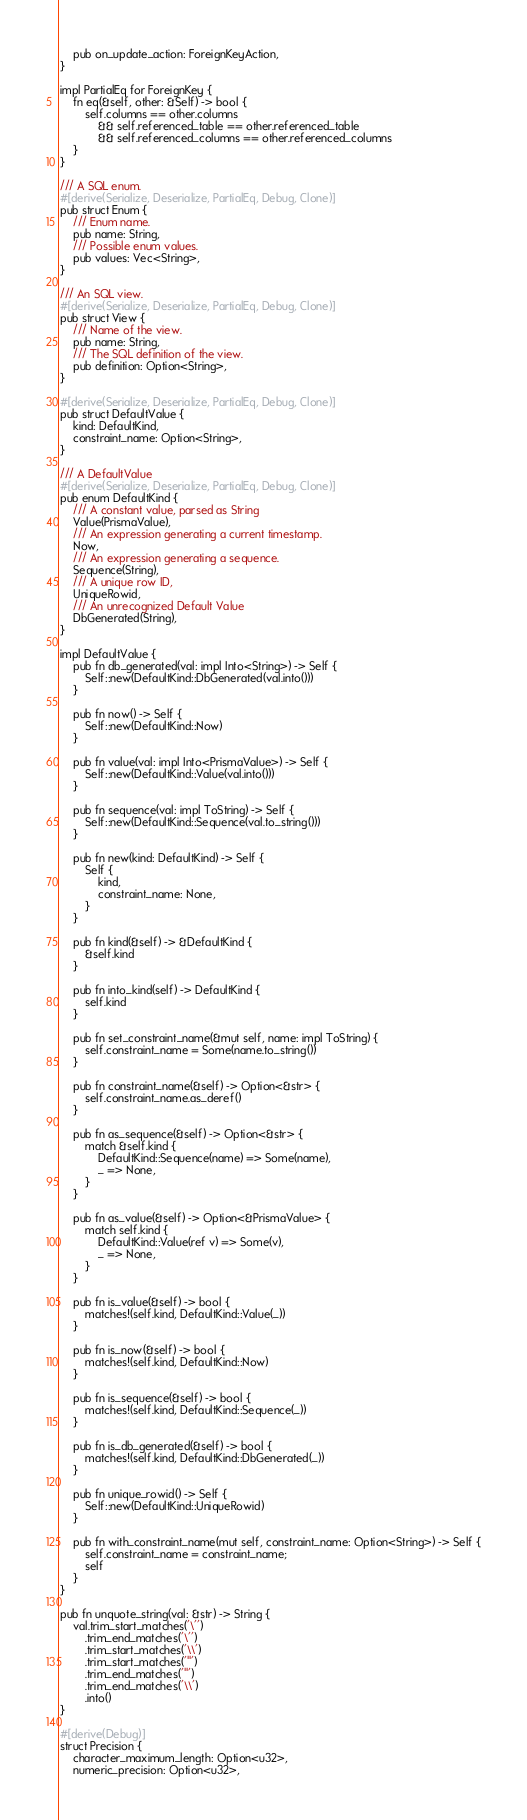Convert code to text. <code><loc_0><loc_0><loc_500><loc_500><_Rust_>    pub on_update_action: ForeignKeyAction,
}

impl PartialEq for ForeignKey {
    fn eq(&self, other: &Self) -> bool {
        self.columns == other.columns
            && self.referenced_table == other.referenced_table
            && self.referenced_columns == other.referenced_columns
    }
}

/// A SQL enum.
#[derive(Serialize, Deserialize, PartialEq, Debug, Clone)]
pub struct Enum {
    /// Enum name.
    pub name: String,
    /// Possible enum values.
    pub values: Vec<String>,
}

/// An SQL view.
#[derive(Serialize, Deserialize, PartialEq, Debug, Clone)]
pub struct View {
    /// Name of the view.
    pub name: String,
    /// The SQL definition of the view.
    pub definition: Option<String>,
}

#[derive(Serialize, Deserialize, PartialEq, Debug, Clone)]
pub struct DefaultValue {
    kind: DefaultKind,
    constraint_name: Option<String>,
}

/// A DefaultValue
#[derive(Serialize, Deserialize, PartialEq, Debug, Clone)]
pub enum DefaultKind {
    /// A constant value, parsed as String
    Value(PrismaValue),
    /// An expression generating a current timestamp.
    Now,
    /// An expression generating a sequence.
    Sequence(String),
    /// A unique row ID,
    UniqueRowid,
    /// An unrecognized Default Value
    DbGenerated(String),
}

impl DefaultValue {
    pub fn db_generated(val: impl Into<String>) -> Self {
        Self::new(DefaultKind::DbGenerated(val.into()))
    }

    pub fn now() -> Self {
        Self::new(DefaultKind::Now)
    }

    pub fn value(val: impl Into<PrismaValue>) -> Self {
        Self::new(DefaultKind::Value(val.into()))
    }

    pub fn sequence(val: impl ToString) -> Self {
        Self::new(DefaultKind::Sequence(val.to_string()))
    }

    pub fn new(kind: DefaultKind) -> Self {
        Self {
            kind,
            constraint_name: None,
        }
    }

    pub fn kind(&self) -> &DefaultKind {
        &self.kind
    }

    pub fn into_kind(self) -> DefaultKind {
        self.kind
    }

    pub fn set_constraint_name(&mut self, name: impl ToString) {
        self.constraint_name = Some(name.to_string())
    }

    pub fn constraint_name(&self) -> Option<&str> {
        self.constraint_name.as_deref()
    }

    pub fn as_sequence(&self) -> Option<&str> {
        match &self.kind {
            DefaultKind::Sequence(name) => Some(name),
            _ => None,
        }
    }

    pub fn as_value(&self) -> Option<&PrismaValue> {
        match self.kind {
            DefaultKind::Value(ref v) => Some(v),
            _ => None,
        }
    }

    pub fn is_value(&self) -> bool {
        matches!(self.kind, DefaultKind::Value(_))
    }

    pub fn is_now(&self) -> bool {
        matches!(self.kind, DefaultKind::Now)
    }

    pub fn is_sequence(&self) -> bool {
        matches!(self.kind, DefaultKind::Sequence(_))
    }

    pub fn is_db_generated(&self) -> bool {
        matches!(self.kind, DefaultKind::DbGenerated(_))
    }

    pub fn unique_rowid() -> Self {
        Self::new(DefaultKind::UniqueRowid)
    }

    pub fn with_constraint_name(mut self, constraint_name: Option<String>) -> Self {
        self.constraint_name = constraint_name;
        self
    }
}

pub fn unquote_string(val: &str) -> String {
    val.trim_start_matches('\'')
        .trim_end_matches('\'')
        .trim_start_matches('\\')
        .trim_start_matches('"')
        .trim_end_matches('"')
        .trim_end_matches('\\')
        .into()
}

#[derive(Debug)]
struct Precision {
    character_maximum_length: Option<u32>,
    numeric_precision: Option<u32>,</code> 